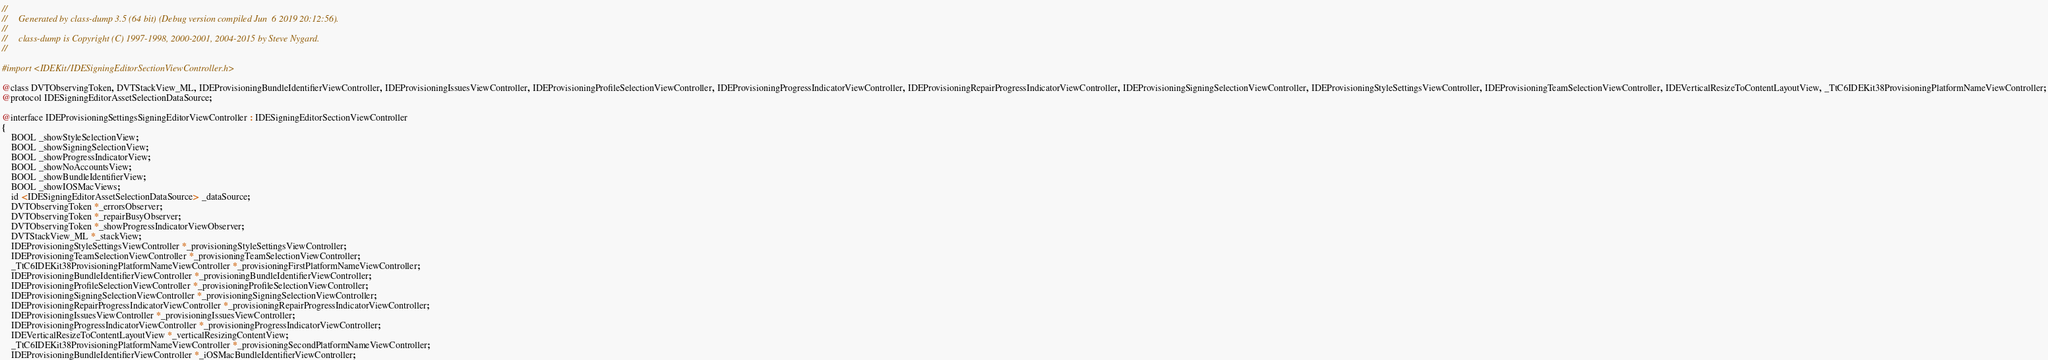<code> <loc_0><loc_0><loc_500><loc_500><_C_>//
//     Generated by class-dump 3.5 (64 bit) (Debug version compiled Jun  6 2019 20:12:56).
//
//     class-dump is Copyright (C) 1997-1998, 2000-2001, 2004-2015 by Steve Nygard.
//

#import <IDEKit/IDESigningEditorSectionViewController.h>

@class DVTObservingToken, DVTStackView_ML, IDEProvisioningBundleIdentifierViewController, IDEProvisioningIssuesViewController, IDEProvisioningProfileSelectionViewController, IDEProvisioningProgressIndicatorViewController, IDEProvisioningRepairProgressIndicatorViewController, IDEProvisioningSigningSelectionViewController, IDEProvisioningStyleSettingsViewController, IDEProvisioningTeamSelectionViewController, IDEVerticalResizeToContentLayoutView, _TtC6IDEKit38ProvisioningPlatformNameViewController;
@protocol IDESigningEditorAssetSelectionDataSource;

@interface IDEProvisioningSettingsSigningEditorViewController : IDESigningEditorSectionViewController
{
    BOOL _showStyleSelectionView;
    BOOL _showSigningSelectionView;
    BOOL _showProgressIndicatorView;
    BOOL _showNoAccountsView;
    BOOL _showBundleIdentifierView;
    BOOL _showIOSMacViews;
    id <IDESigningEditorAssetSelectionDataSource> _dataSource;
    DVTObservingToken *_errorsObserver;
    DVTObservingToken *_repairBusyObserver;
    DVTObservingToken *_showProgressIndicatorViewObserver;
    DVTStackView_ML *_stackView;
    IDEProvisioningStyleSettingsViewController *_provisioningStyleSettingsViewController;
    IDEProvisioningTeamSelectionViewController *_provisioningTeamSelectionViewController;
    _TtC6IDEKit38ProvisioningPlatformNameViewController *_provisioningFirstPlatformNameViewController;
    IDEProvisioningBundleIdentifierViewController *_provisioningBundleIdentifierViewController;
    IDEProvisioningProfileSelectionViewController *_provisioningProfileSelectionViewController;
    IDEProvisioningSigningSelectionViewController *_provisioningSigningSelectionViewController;
    IDEProvisioningRepairProgressIndicatorViewController *_provisioningRepairProgressIndicatorViewController;
    IDEProvisioningIssuesViewController *_provisioningIssuesViewController;
    IDEProvisioningProgressIndicatorViewController *_provisioningProgressIndicatorViewController;
    IDEVerticalResizeToContentLayoutView *_verticalResizingContentView;
    _TtC6IDEKit38ProvisioningPlatformNameViewController *_provisioningSecondPlatformNameViewController;
    IDEProvisioningBundleIdentifierViewController *_iOSMacBundleIdentifierViewController;</code> 